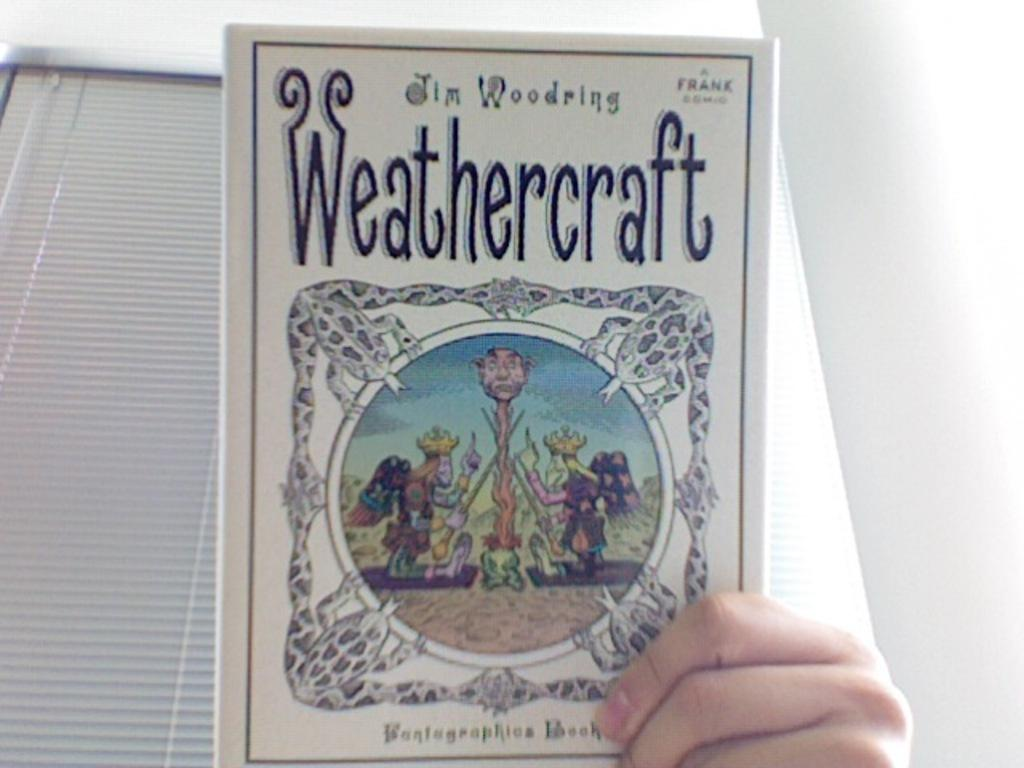<image>
Give a short and clear explanation of the subsequent image. Someone holding a book with the title Weathercraft. 